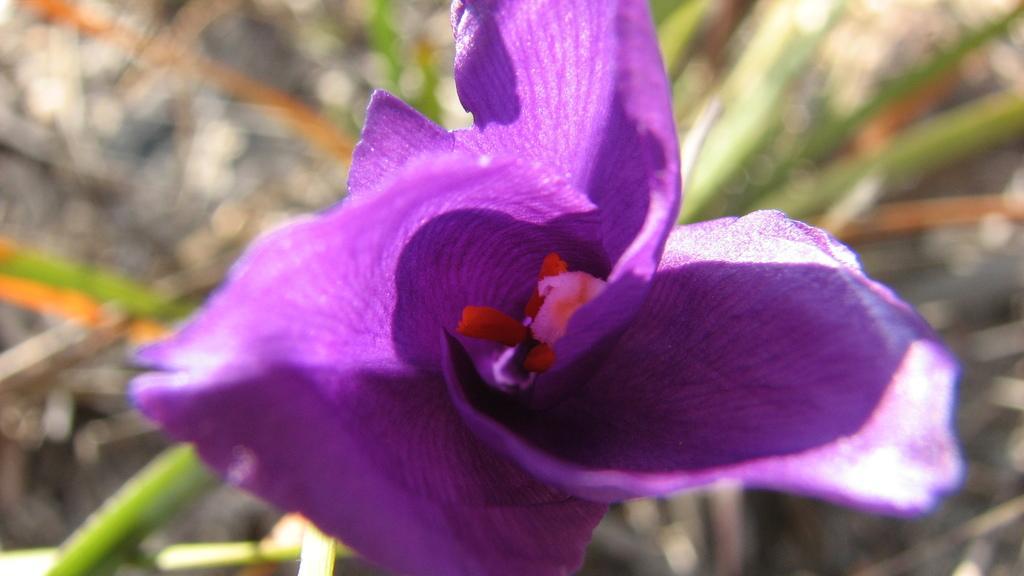In one or two sentences, can you explain what this image depicts? In this image we can see a purple color flower and the background is blurred. 